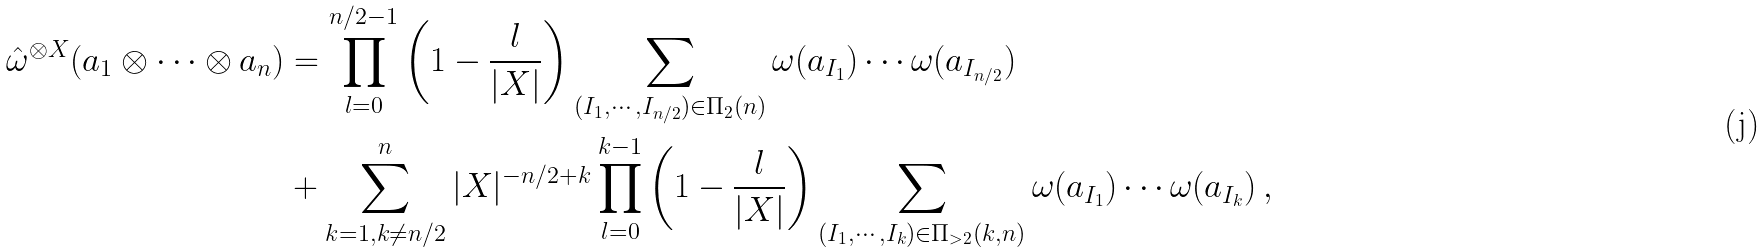Convert formula to latex. <formula><loc_0><loc_0><loc_500><loc_500>\hat { \omega } ^ { \otimes X } ( a _ { 1 } \otimes \cdots \otimes a _ { n } ) & = \prod _ { l = 0 } ^ { n / 2 - 1 } \left ( 1 - \frac { l } { | X | } \right ) \sum _ { ( I _ { 1 } , \cdots , I _ { n / 2 } ) \in \Pi _ { 2 } ( n ) } \omega ( a _ { I _ { 1 } } ) \cdots \omega ( a _ { I _ { n / 2 } } ) \\ & + \sum _ { k = 1 , k \not = n / 2 } ^ { n } | X | ^ { - n / 2 + k } \prod _ { l = 0 } ^ { k - 1 } \left ( 1 - \frac { l } { | X | } \right ) \sum _ { ( I _ { 1 } , \cdots , I _ { k } ) \in \Pi _ { > 2 } ( k , n ) } \omega ( a _ { I _ { 1 } } ) \cdots \omega ( a _ { I _ { k } } ) \, ,</formula> 